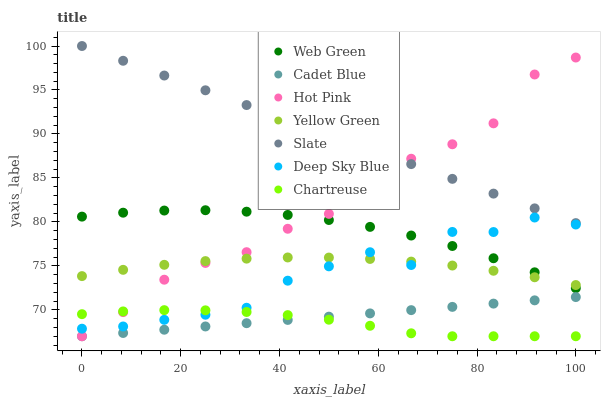Does Chartreuse have the minimum area under the curve?
Answer yes or no. Yes. Does Slate have the maximum area under the curve?
Answer yes or no. Yes. Does Yellow Green have the minimum area under the curve?
Answer yes or no. No. Does Yellow Green have the maximum area under the curve?
Answer yes or no. No. Is Cadet Blue the smoothest?
Answer yes or no. Yes. Is Deep Sky Blue the roughest?
Answer yes or no. Yes. Is Yellow Green the smoothest?
Answer yes or no. No. Is Yellow Green the roughest?
Answer yes or no. No. Does Cadet Blue have the lowest value?
Answer yes or no. Yes. Does Yellow Green have the lowest value?
Answer yes or no. No. Does Slate have the highest value?
Answer yes or no. Yes. Does Yellow Green have the highest value?
Answer yes or no. No. Is Deep Sky Blue less than Slate?
Answer yes or no. Yes. Is Slate greater than Cadet Blue?
Answer yes or no. Yes. Does Chartreuse intersect Hot Pink?
Answer yes or no. Yes. Is Chartreuse less than Hot Pink?
Answer yes or no. No. Is Chartreuse greater than Hot Pink?
Answer yes or no. No. Does Deep Sky Blue intersect Slate?
Answer yes or no. No. 